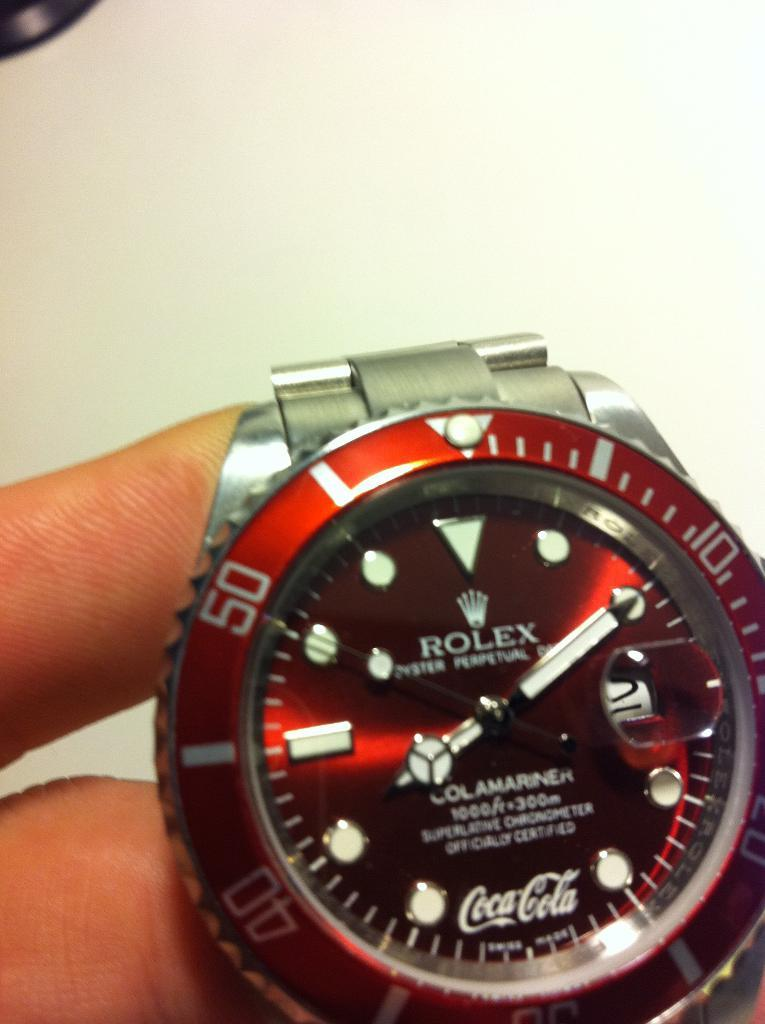<image>
Provide a brief description of the given image. A rolex watch with a blue surrounding and the number 50 visible. 